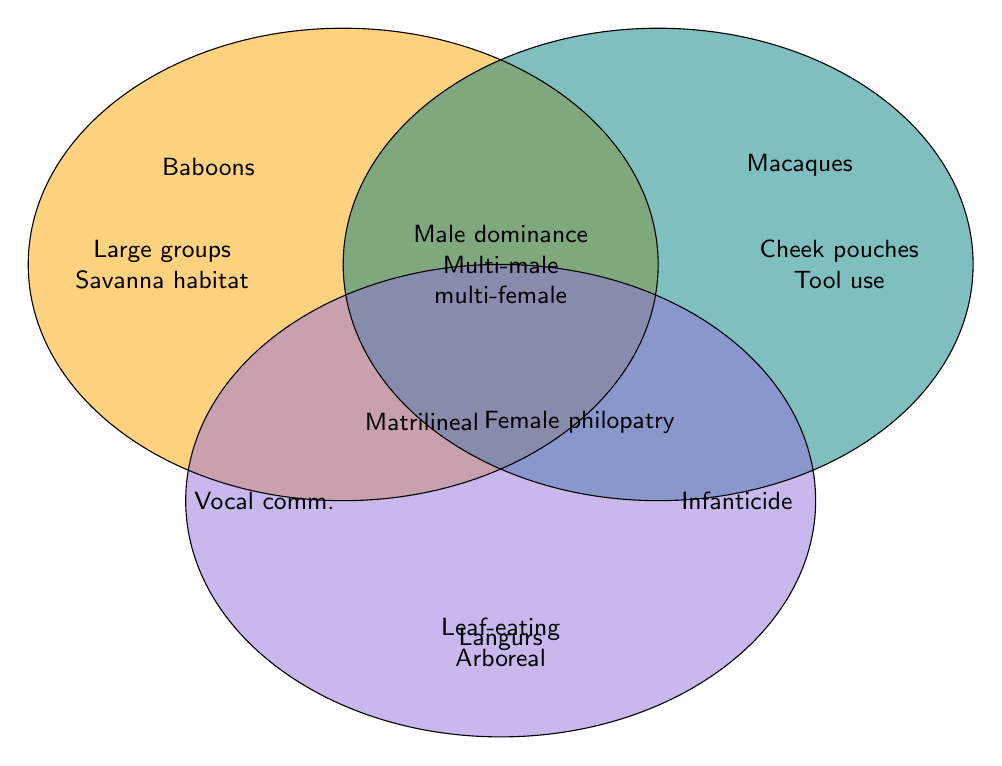What are the shared social structures between baboons and macaques? According to the Venn Diagram, the overlapping section between baboons and macaques shows "Male dominance hierarchy," "Multi-male multi-female groups," and "Matrilineal inheritance."
Answer: Male dominance hierarchy, Multi-male multi-female groups, Matrilineal inheritance Which social structure is unique to langurs concerning infanticide? The Venn Diagram shows that "Infanticide by new males" is listed under langurs but not shared with baboons or macaques.
Answer: Infanticide by new males What distinguishes baboons in terms of habitat compared to macaques and langurs? Baboons have "Savanna habitat," which is not shared with either macaques (with "Diverse habitats") or langurs (with "Arboreal lifestyle").
Answer: Savanna habitat How many shared social structures exist between all three groups? The shared section between all three groups indicates two shared social structures: "Male dominance hierarchy" and "Multi-male multi-female groups."
Answer: Two What specific diet specialization is listed for langurs, and how does it compare to baboons? Langurs are described with a "Leaf-eating diet," while baboons do not have a specific diet specialization listed.
Answer: Leaf-eating diet List the social structures that are common between baboons and langurs but not shared with macaques. The Venn Diagram does not show direct overlaps specific to baboons and langurs that macaques do not share. Thus, there's no entry in that intersection.
Answer: None Which primate group is associated with using tools, and is it a unique characteristic? The Venn Diagram shows "Tool use" under macaques, making it unique to them as neither baboons nor langurs share this trait.
Answer: Macaques What form of communication method is unique to baboons? The Venn Diagram indicates "Vocal communication" under baboons that is not shared with either macaques or langurs.
Answer: Vocal communication 